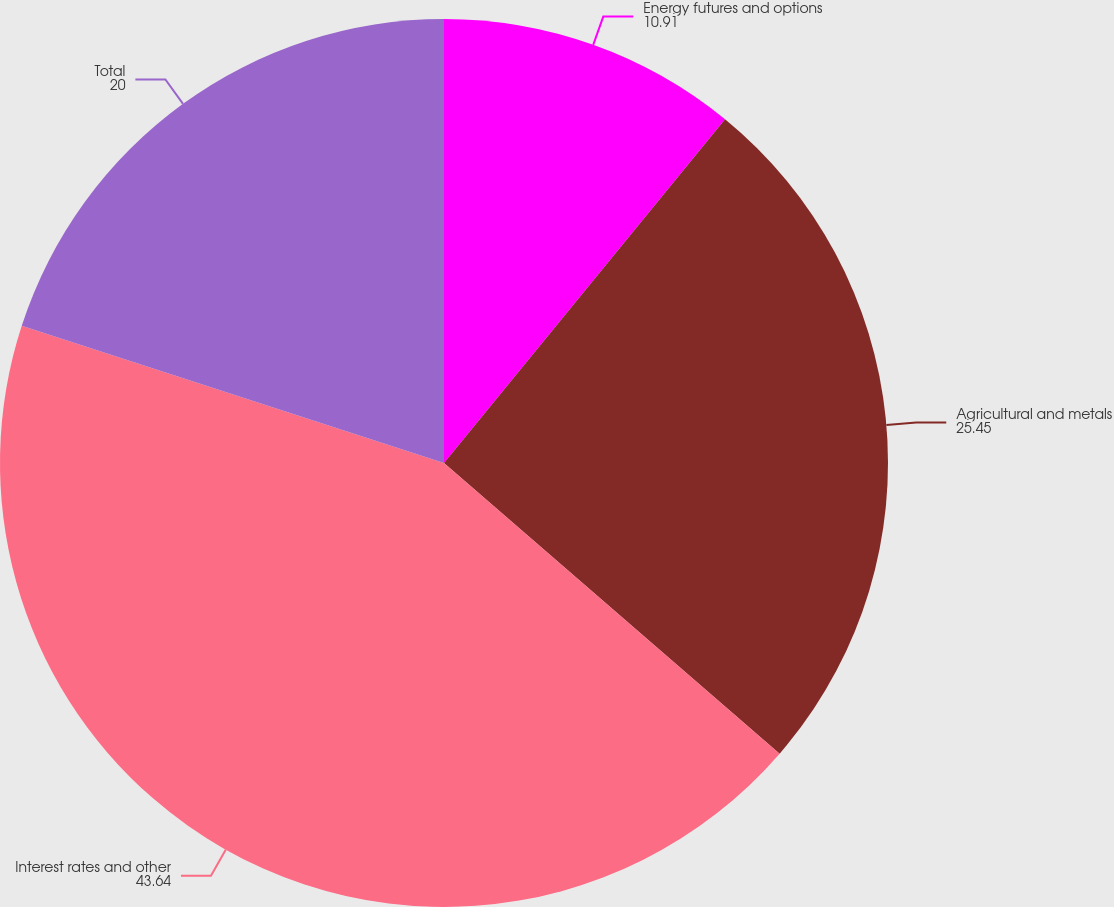Convert chart to OTSL. <chart><loc_0><loc_0><loc_500><loc_500><pie_chart><fcel>Energy futures and options<fcel>Agricultural and metals<fcel>Interest rates and other<fcel>Total<nl><fcel>10.91%<fcel>25.45%<fcel>43.64%<fcel>20.0%<nl></chart> 